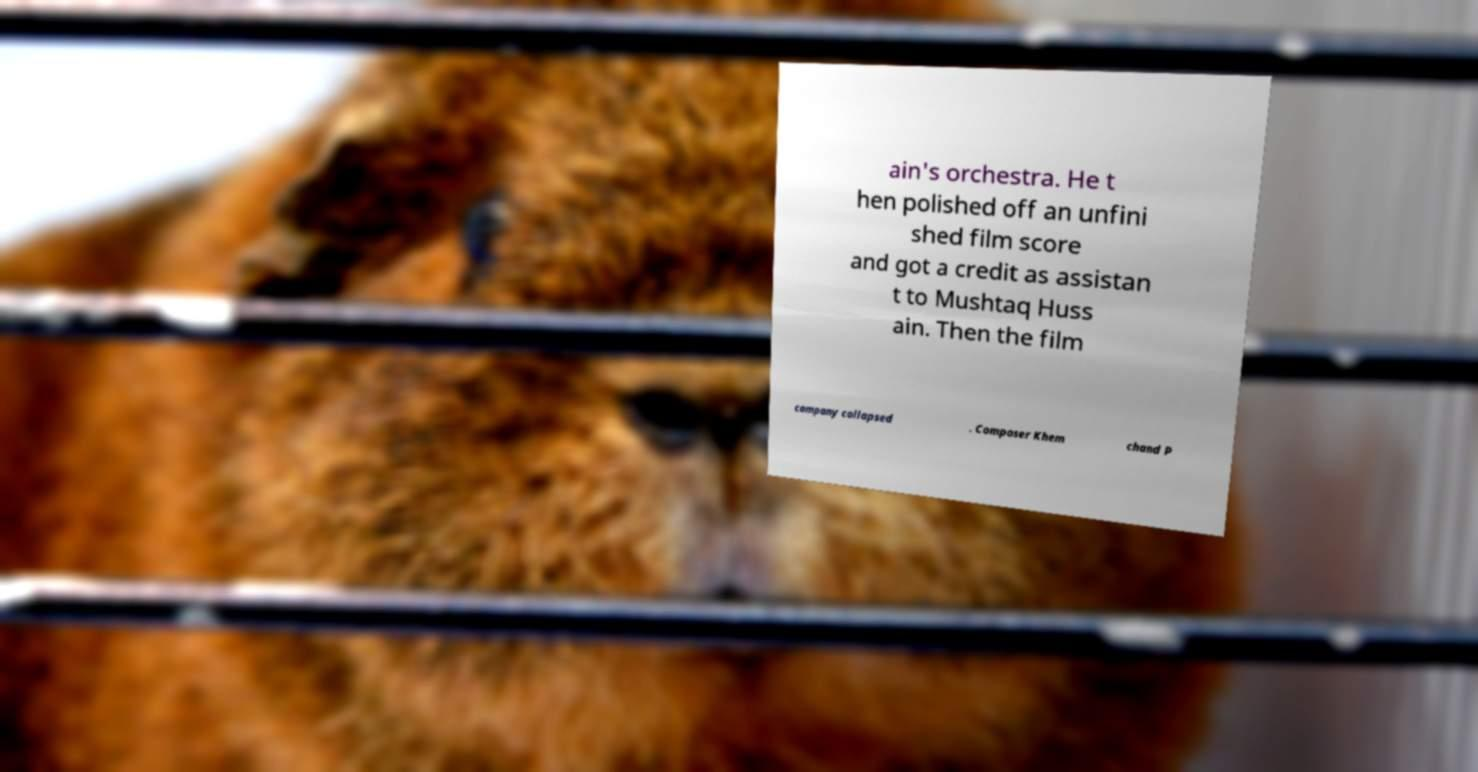There's text embedded in this image that I need extracted. Can you transcribe it verbatim? ain's orchestra. He t hen polished off an unfini shed film score and got a credit as assistan t to Mushtaq Huss ain. Then the film company collapsed . Composer Khem chand P 